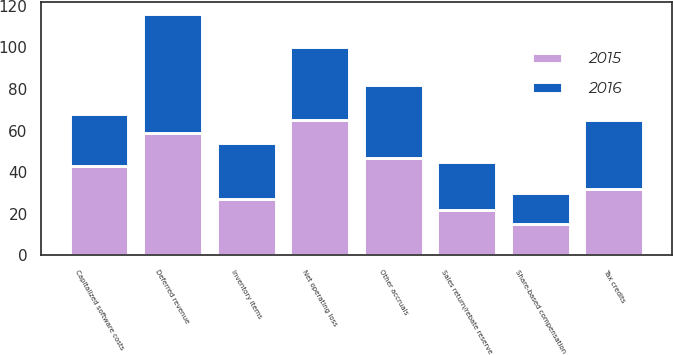Convert chart. <chart><loc_0><loc_0><loc_500><loc_500><stacked_bar_chart><ecel><fcel>Deferred revenue<fcel>Tax credits<fcel>Net operating loss<fcel>Other accruals<fcel>Inventory items<fcel>Capitalized software costs<fcel>Sales return/rebate reserve<fcel>Share-based compensation<nl><fcel>2016<fcel>57<fcel>33<fcel>35<fcel>35<fcel>27<fcel>25<fcel>23<fcel>15<nl><fcel>2015<fcel>59<fcel>32<fcel>65<fcel>47<fcel>27<fcel>43<fcel>22<fcel>15<nl></chart> 